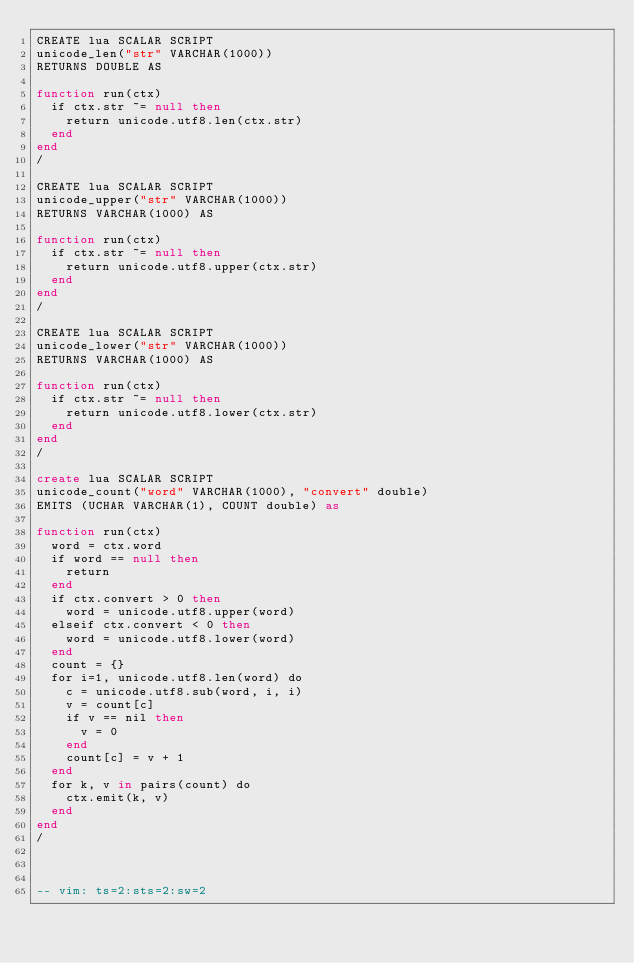Convert code to text. <code><loc_0><loc_0><loc_500><loc_500><_SQL_>CREATE lua SCALAR SCRIPT
unicode_len("str" VARCHAR(1000))
RETURNS DOUBLE AS

function run(ctx)
	if ctx.str ~= null then
		return unicode.utf8.len(ctx.str)
	end
end
/

CREATE lua SCALAR SCRIPT
unicode_upper("str" VARCHAR(1000))
RETURNS VARCHAR(1000) AS

function run(ctx)
	if ctx.str ~= null then
		return unicode.utf8.upper(ctx.str)
	end
end
/

CREATE lua SCALAR SCRIPT
unicode_lower("str" VARCHAR(1000))
RETURNS VARCHAR(1000) AS

function run(ctx)
	if ctx.str ~= null then
		return unicode.utf8.lower(ctx.str)
	end
end
/

create lua SCALAR SCRIPT
unicode_count("word" VARCHAR(1000), "convert" double)
EMITS (UCHAR VARCHAR(1), COUNT double) as

function run(ctx)
	word = ctx.word
	if word == null then
		return
	end
	if ctx.convert > 0 then
		word = unicode.utf8.upper(word)
	elseif ctx.convert < 0 then
		word = unicode.utf8.lower(word)
	end
	count = {}
	for i=1, unicode.utf8.len(word) do
		c = unicode.utf8.sub(word, i, i)
		v = count[c]
		if v == nil then
			v = 0
		end
		count[c] = v + 1
	end
	for k, v in pairs(count) do
		ctx.emit(k, v)
	end
end
/



-- vim: ts=2:sts=2:sw=2
</code> 